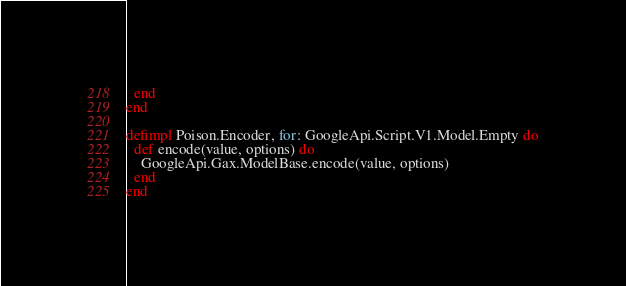Convert code to text. <code><loc_0><loc_0><loc_500><loc_500><_Elixir_>  end
end

defimpl Poison.Encoder, for: GoogleApi.Script.V1.Model.Empty do
  def encode(value, options) do
    GoogleApi.Gax.ModelBase.encode(value, options)
  end
end
</code> 